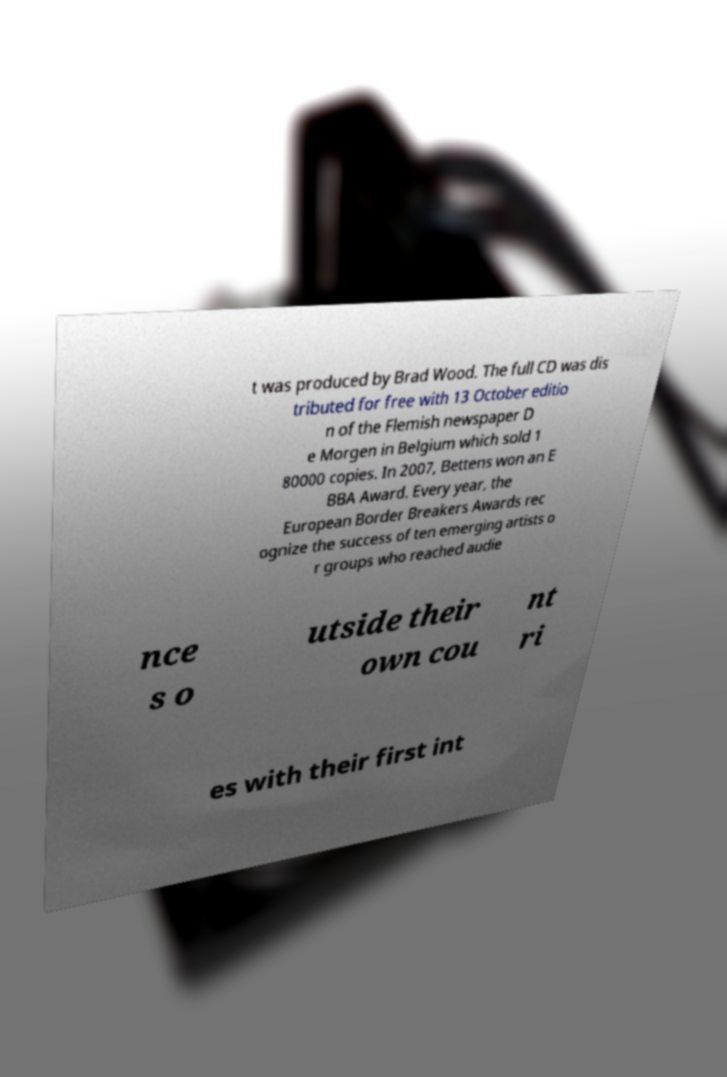Can you read and provide the text displayed in the image?This photo seems to have some interesting text. Can you extract and type it out for me? t was produced by Brad Wood. The full CD was dis tributed for free with 13 October editio n of the Flemish newspaper D e Morgen in Belgium which sold 1 80000 copies. In 2007, Bettens won an E BBA Award. Every year, the European Border Breakers Awards rec ognize the success of ten emerging artists o r groups who reached audie nce s o utside their own cou nt ri es with their first int 